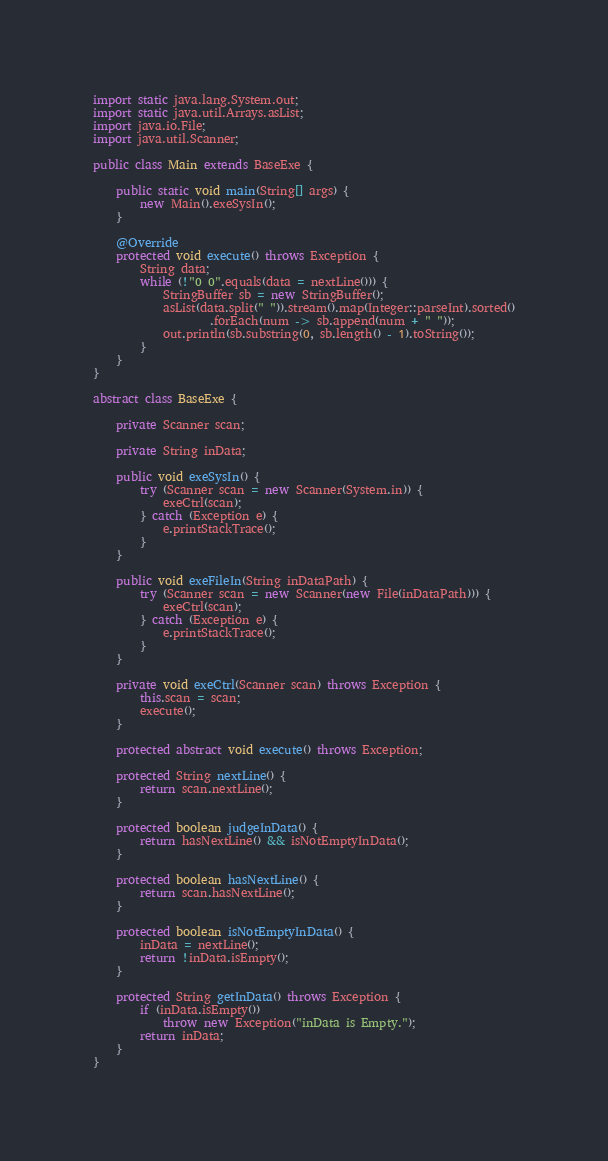<code> <loc_0><loc_0><loc_500><loc_500><_Java_>import static java.lang.System.out;
import static java.util.Arrays.asList;
import java.io.File;
import java.util.Scanner;

public class Main extends BaseExe {

    public static void main(String[] args) {
        new Main().exeSysIn();
    }

    @Override
    protected void execute() throws Exception {
        String data;
        while (!"0 0".equals(data = nextLine())) {
            StringBuffer sb = new StringBuffer();
            asList(data.split(" ")).stream().map(Integer::parseInt).sorted()
                    .forEach(num -> sb.append(num + " "));
            out.println(sb.substring(0, sb.length() - 1).toString());
        }
    }
}

abstract class BaseExe {

    private Scanner scan;

    private String inData;

    public void exeSysIn() {
        try (Scanner scan = new Scanner(System.in)) {
            exeCtrl(scan);
        } catch (Exception e) {
            e.printStackTrace();
        }
    }

    public void exeFileIn(String inDataPath) {
        try (Scanner scan = new Scanner(new File(inDataPath))) {
            exeCtrl(scan);
        } catch (Exception e) {
            e.printStackTrace();
        }
    }

    private void exeCtrl(Scanner scan) throws Exception {
        this.scan = scan;
        execute();
    }

    protected abstract void execute() throws Exception;

    protected String nextLine() {
        return scan.nextLine();
    }

    protected boolean judgeInData() {
        return hasNextLine() && isNotEmptyInData();
    }

    protected boolean hasNextLine() {
        return scan.hasNextLine();
    }

    protected boolean isNotEmptyInData() {
        inData = nextLine();
        return !inData.isEmpty();
    }

    protected String getInData() throws Exception {
        if (inData.isEmpty())
            throw new Exception("inData is Empty.");
        return inData;
    }
}</code> 